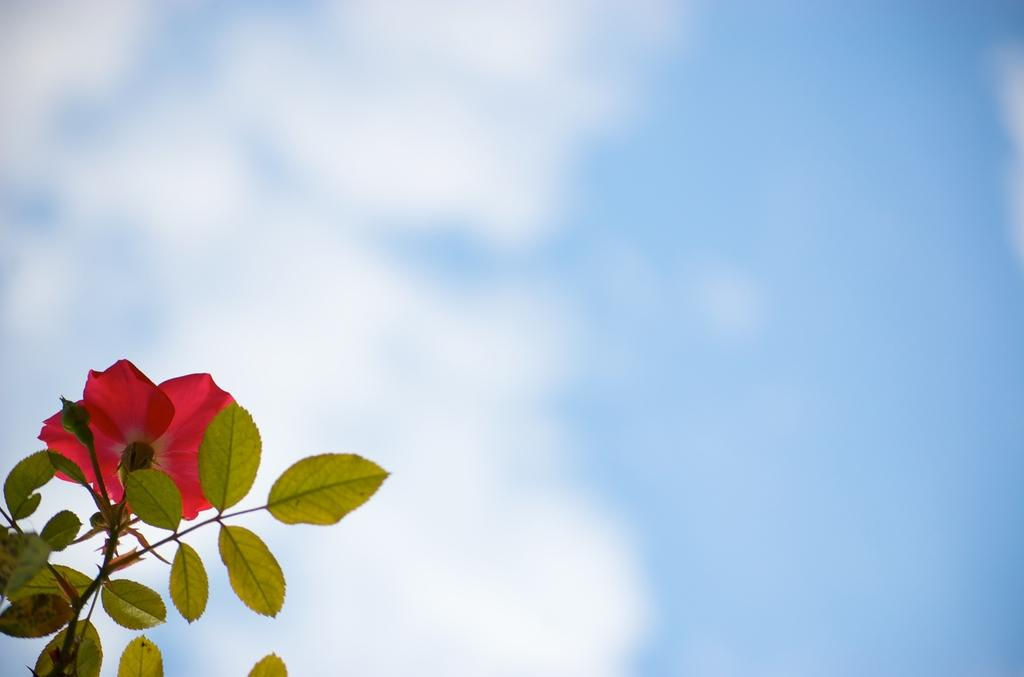What type of plant can be seen in the image? There is a plant with a flower in the image. What is visible in the background of the image? The sky is visible in the image. How would you describe the sky in the image? The sky appears to be cloudy in the image. Can you tell me how many strangers are shaking an orange in the image? There are no strangers or oranges present in the image. 